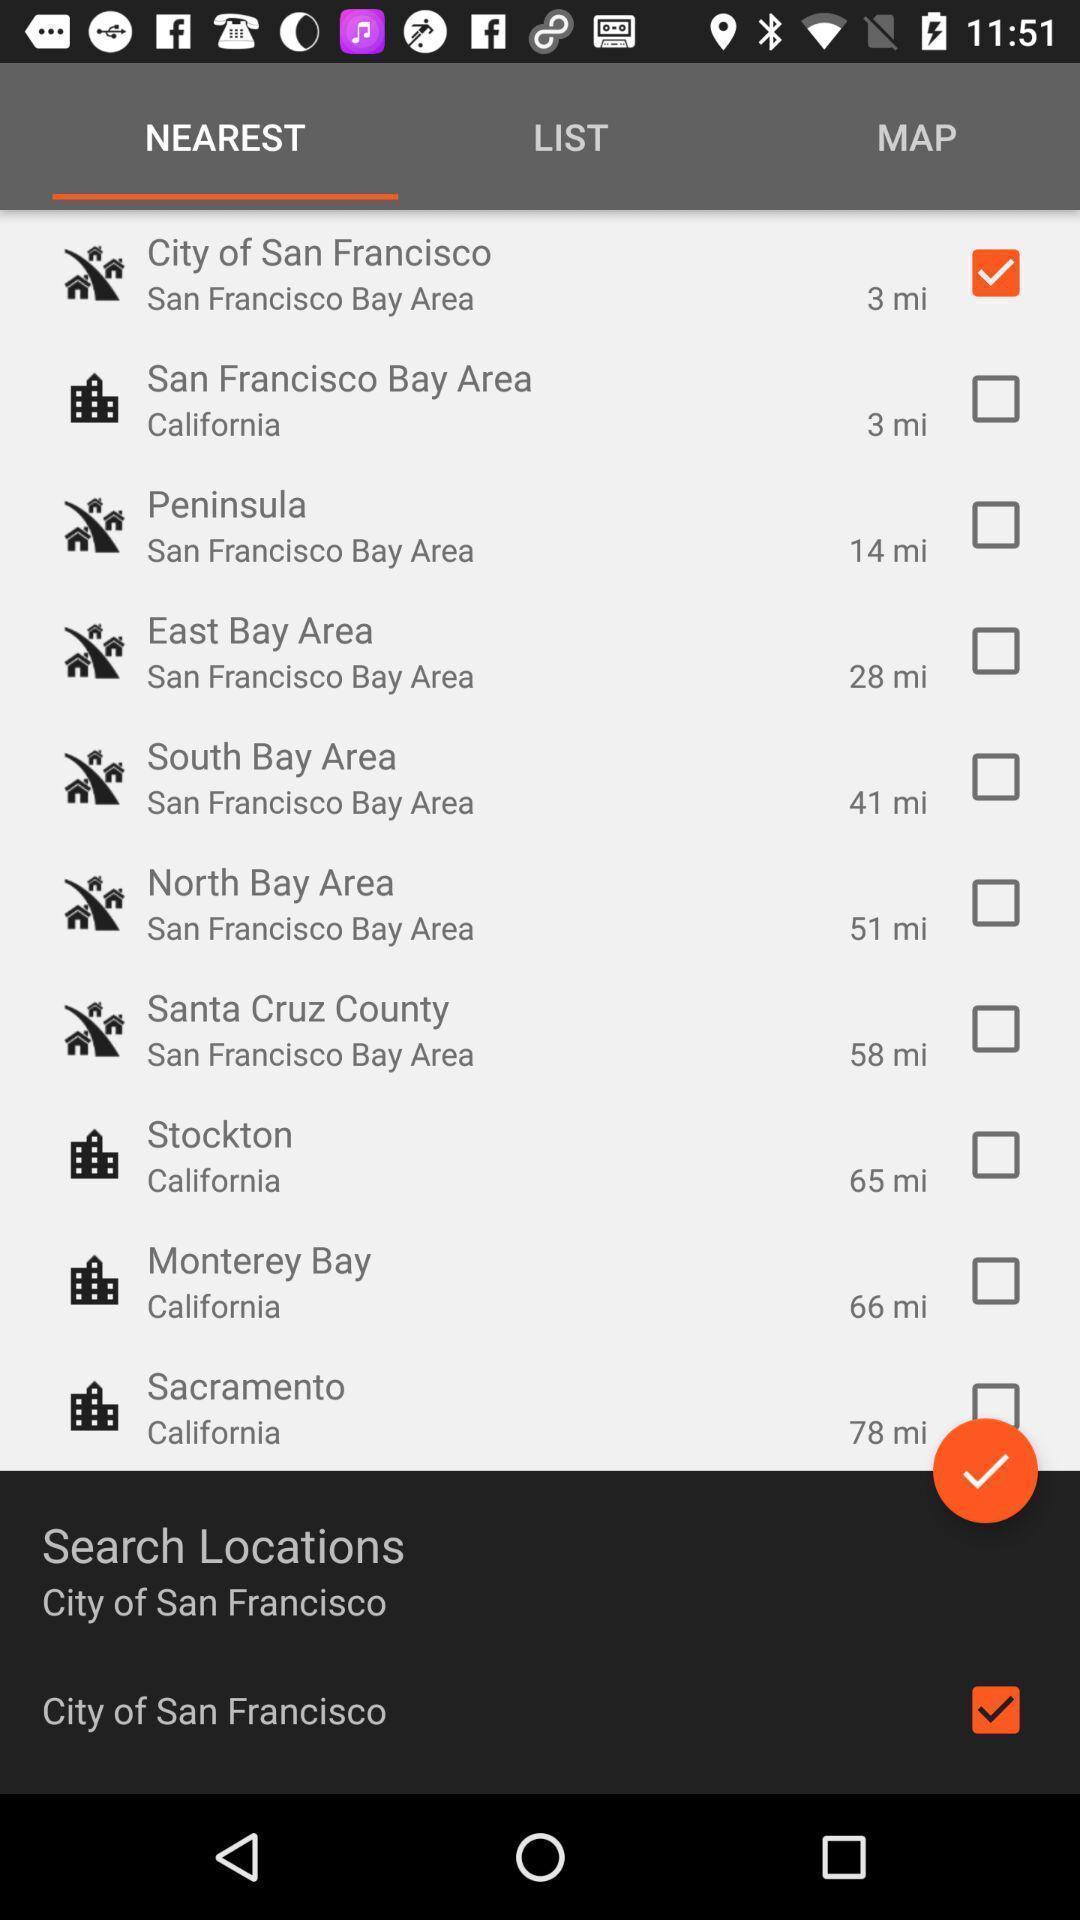Tell me about the visual elements in this screen capture. Results for nearest with few other options in service application. 